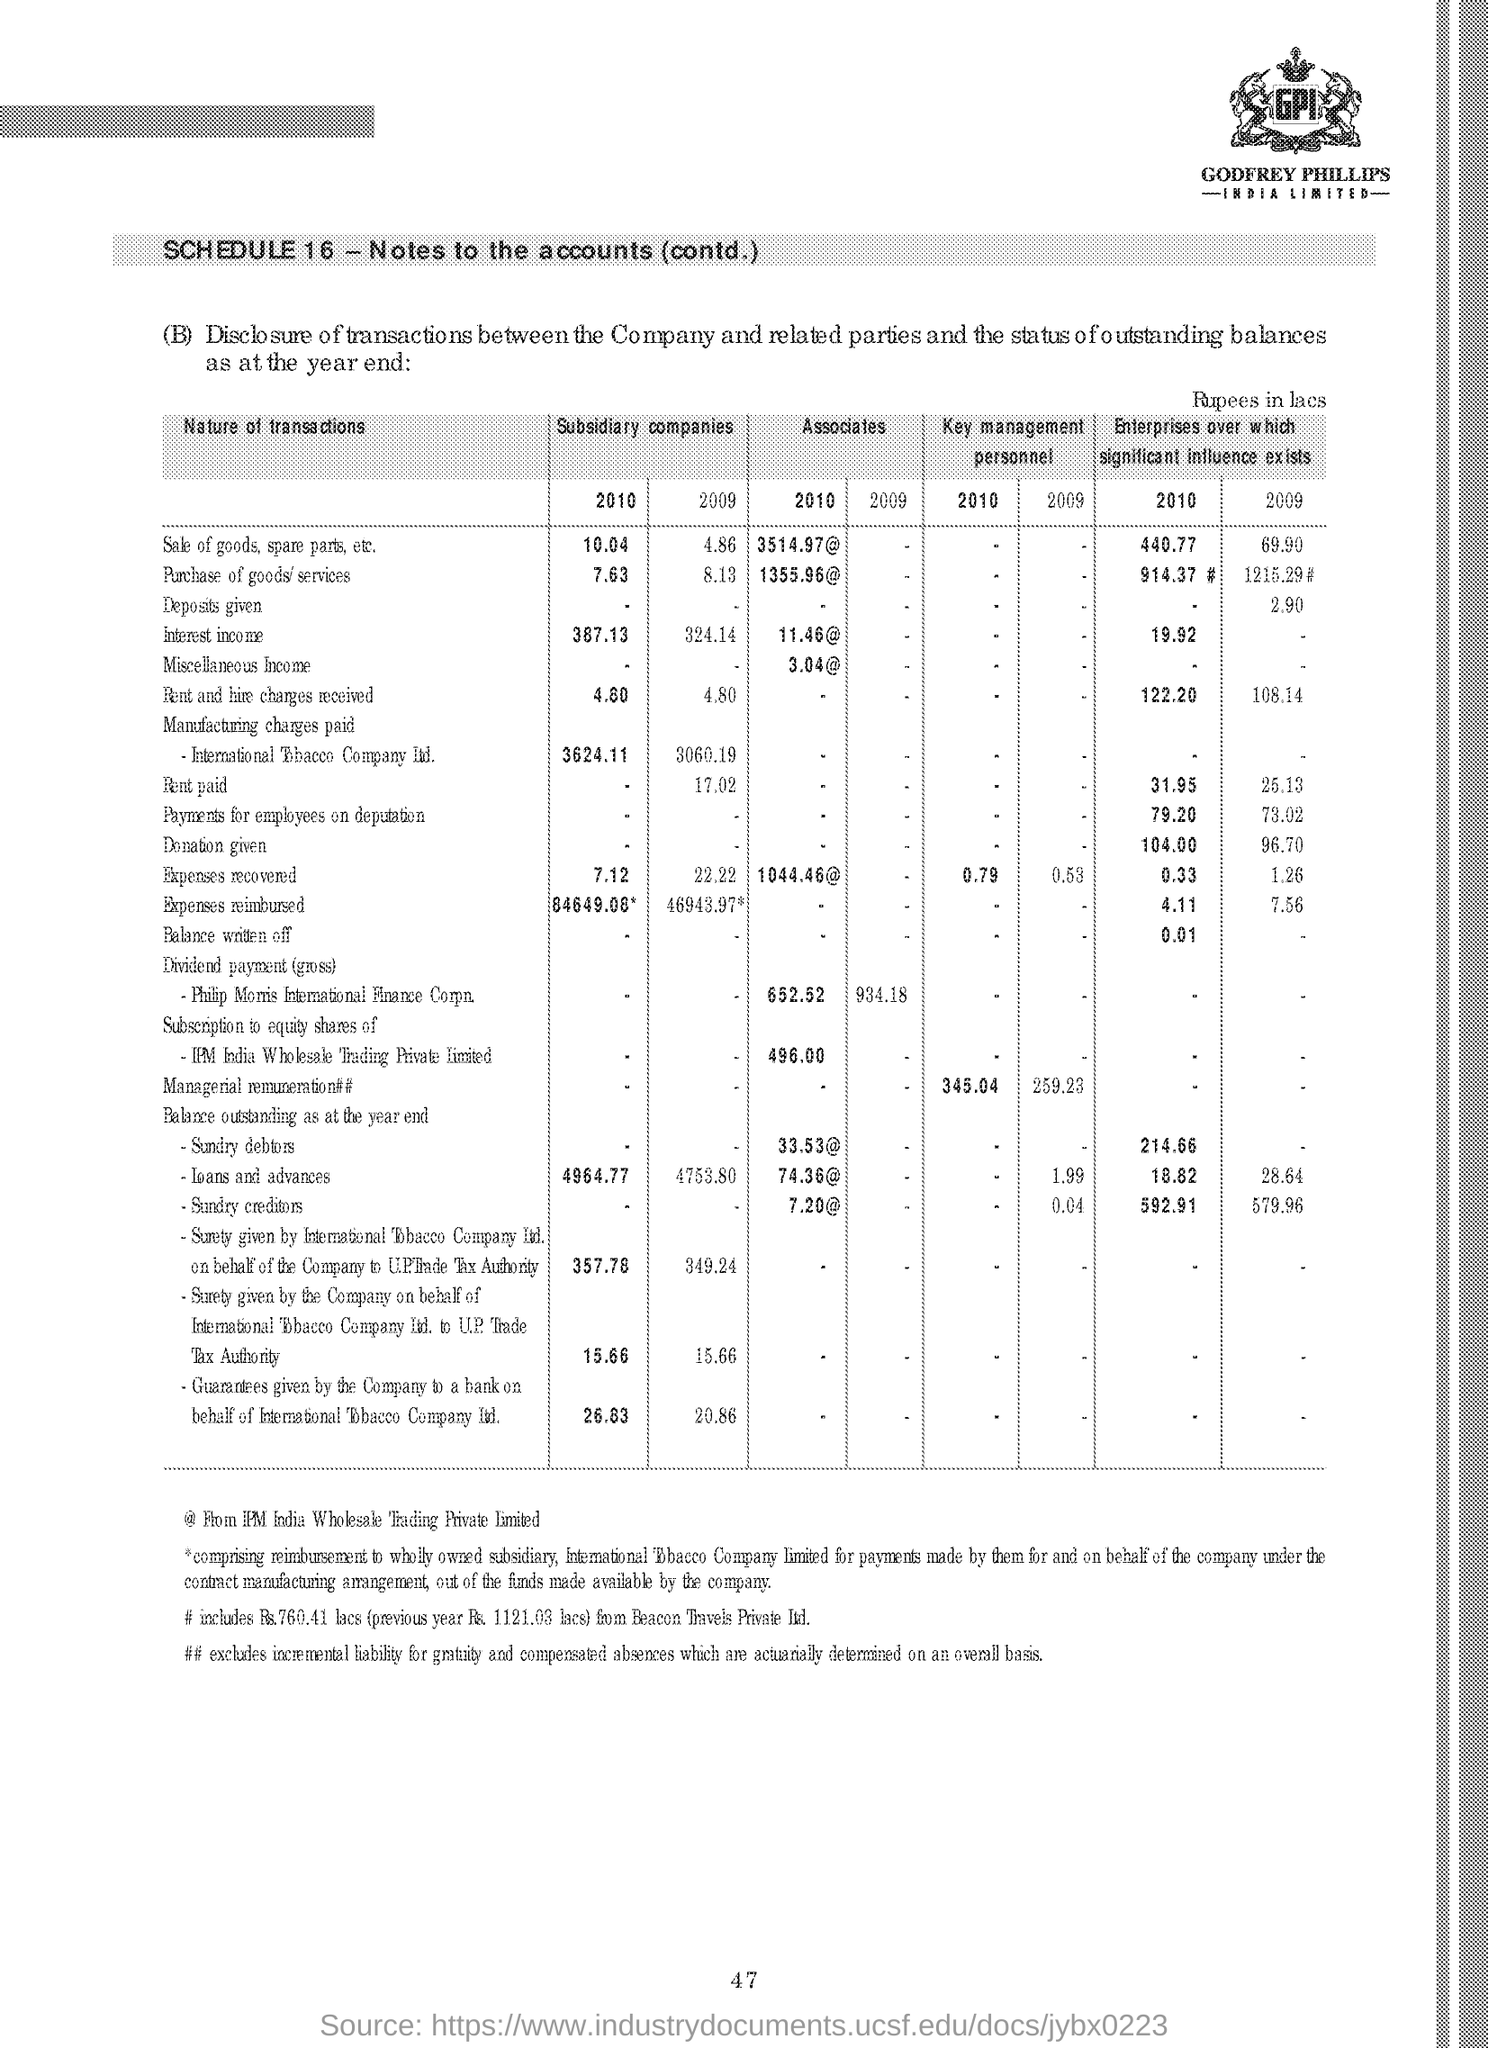how much is the sale of goods, spare parts, etc of subsidiary companies in 2010? In 2010, the sale of goods, spare parts, and similar items by subsidiary companies was 10.04 crore, as indicated in the financial statement. 